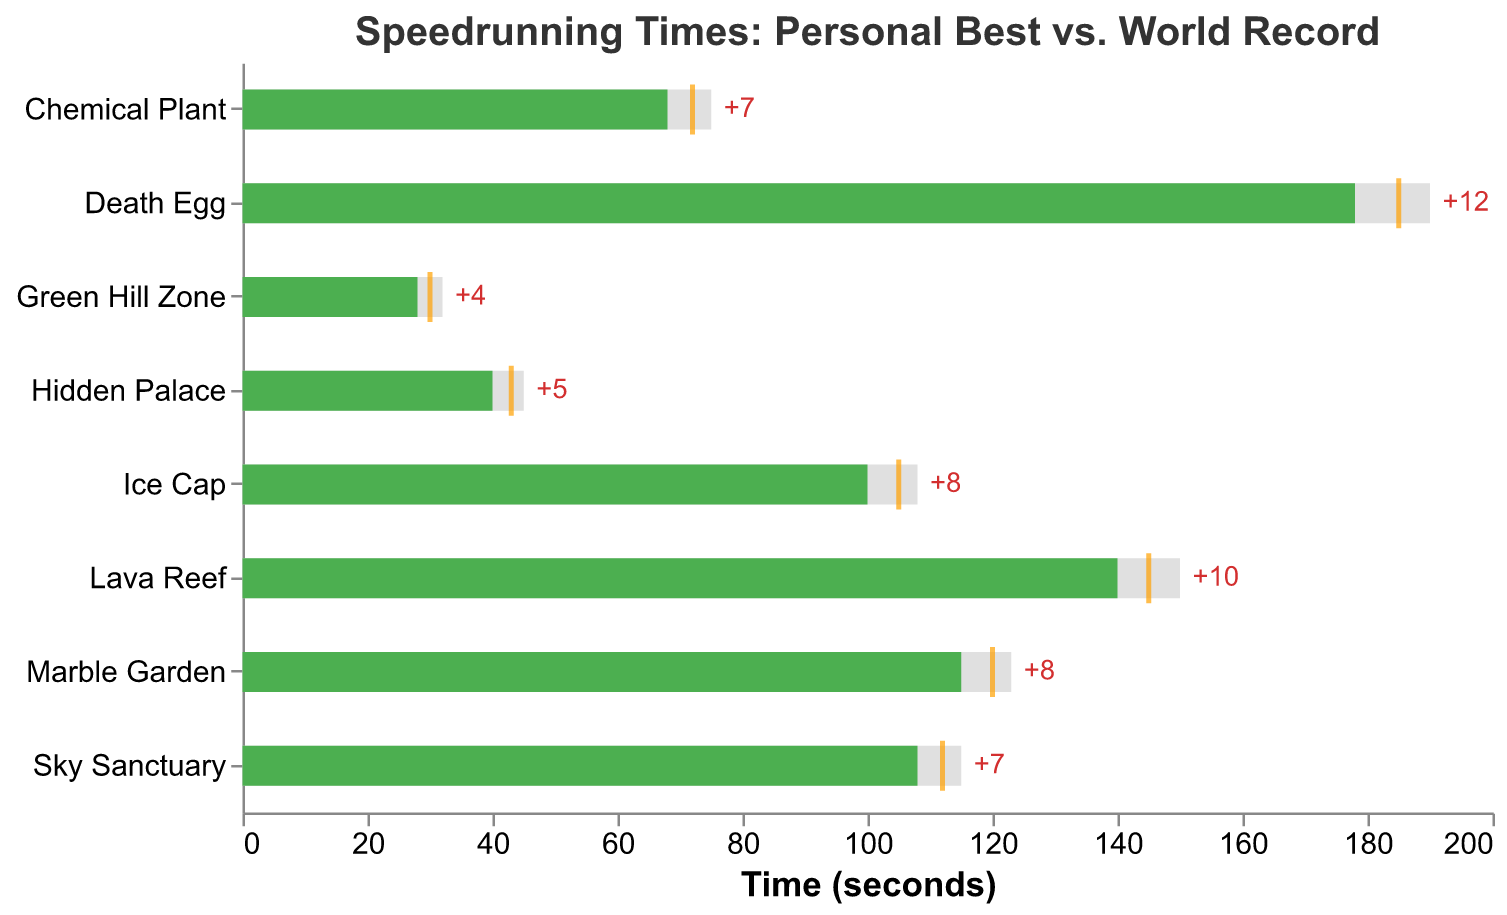What is the title of the figure? The title of the figure is displayed at the top and reads "Speedrunning Times: Personal Best vs. World Record."
Answer: Speedrunning Times: Personal Best vs. World Record What are the three pieces of information represented for each level? Each level displays three pieces of information: Personal Best (given as a light gray bar), World Record (a green bar), and Target (a yellow tick mark).
Answer: Personal Best, World Record, Target Which level has the largest positive difference between Personal Best and World Record? To find the largest positive difference, look at the text labels showing the difference for each level. The largest positive difference is 12 seconds, which occurs for Death Egg.
Answer: Death Egg For the Ice Cap level, is the Personal Best closer to the World Record or the Target? Compare the position of the yellow tick mark (Target) and the green bar (World Record) relative to the Personal Best bar. For Ice Cap, the Personal Best is 8 seconds higher than the World Record and 3 seconds higher than the Target, so it is closer to the Target.
Answer: Target How many levels have a Personal Best that is better than the Target? By examining the bars and tick marks, we see that the Personal Best is lower than the Target for Hidden Palace only.
Answer: One Which level has a Personal Best time closest to the World Record? Look for the smallest numerical value in the PB_Difference text labels. The closest is Green Hill Zone with a difference of 4 seconds.
Answer: Green Hill Zone What is the range of Personal Best times across all levels? The Personal Best times range from a minimum of 32 seconds (Green Hill Zone) to a maximum of 190 seconds (Death Egg).
Answer: 32 to 190 seconds Which level shows the smallest gap between Personal Best and Target? Examine the bar and tick marks for each level. Hidden Palace has the smallest gap with a difference of just 2 seconds.
Answer: Hidden Palace Identify a level where the Target time is exactly between the Personal Best and the World Record. Check if the Target tick mark is centered between the two bars for any levels. For Chemical Plant, the Personal Best (75) is greater and the World Record (68) is lower, with Target (72) in the middle.
Answer: Chemical Plant 